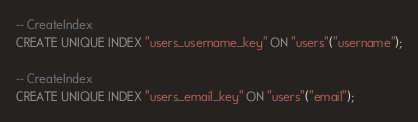Convert code to text. <code><loc_0><loc_0><loc_500><loc_500><_SQL_>-- CreateIndex
CREATE UNIQUE INDEX "users_username_key" ON "users"("username");

-- CreateIndex
CREATE UNIQUE INDEX "users_email_key" ON "users"("email");
</code> 